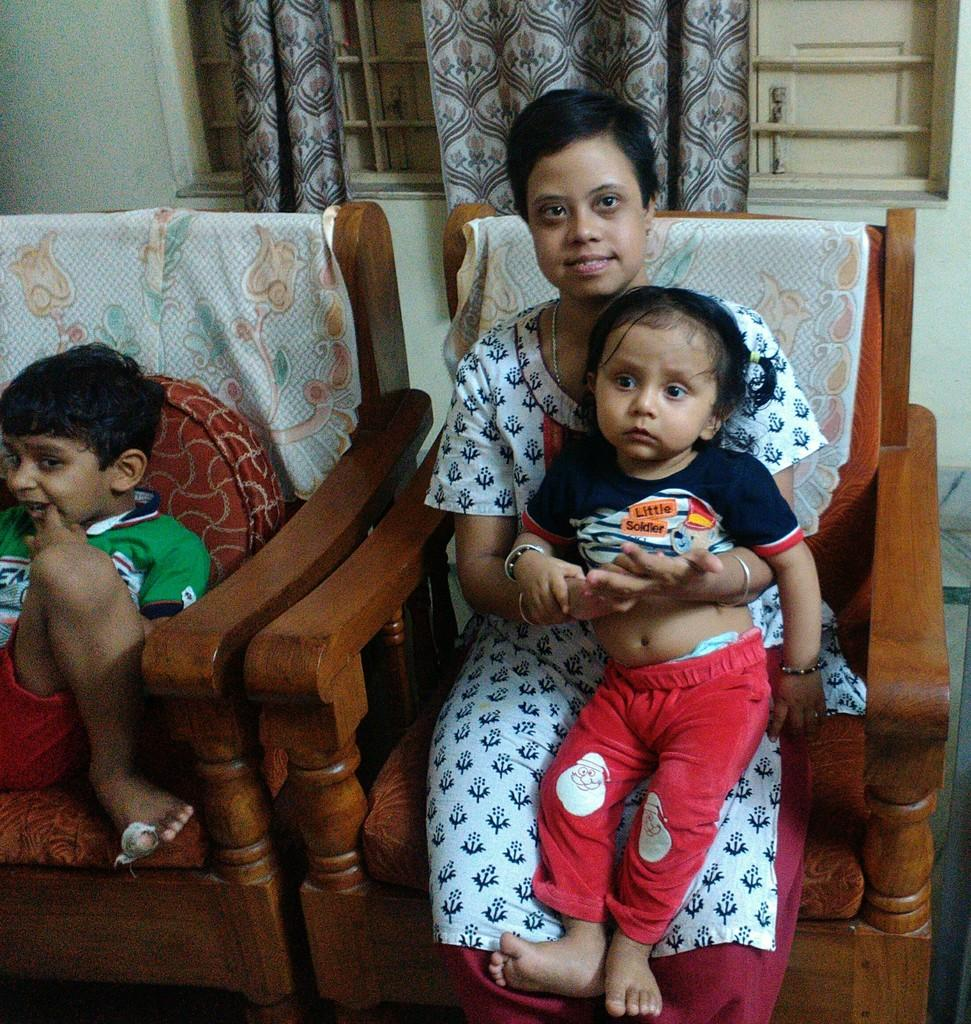What can be seen in the image? There is a group of people in the image, including a boy and a woman. What are the boy and woman doing in the image? The boy and woman are seated on chairs. What can be seen in the background of the image? There are curtains and metal rods in the background. How many eggs are being held by the boy in the image? There are no eggs present in the image. What type of wood is used to make the chairs in the image? There is no information about the material of the chairs in the image. 